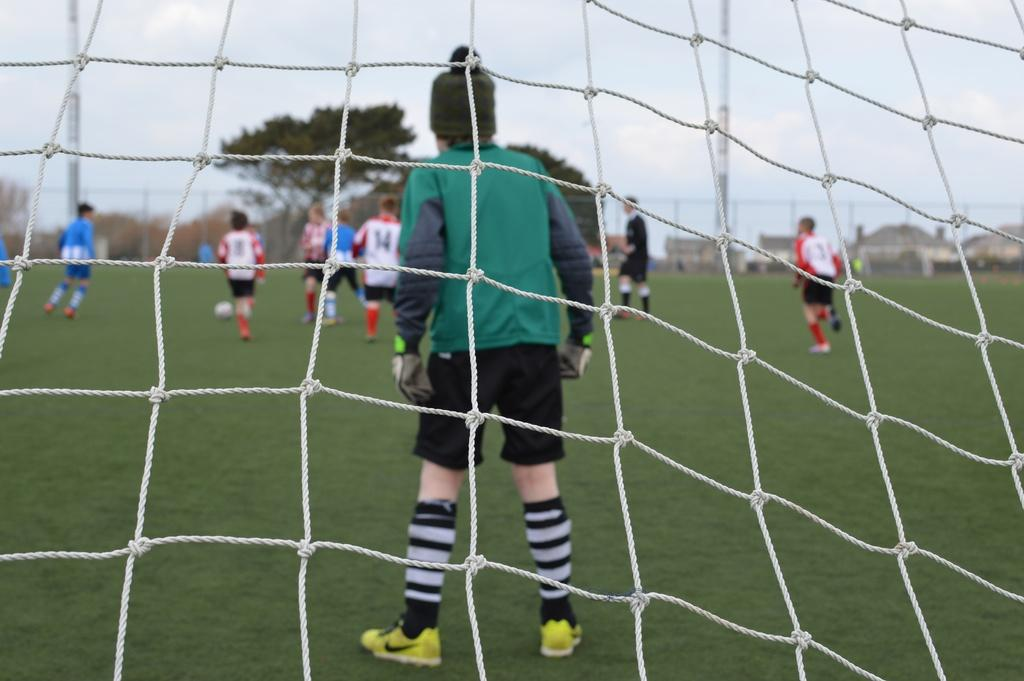Provide a one-sentence caption for the provided image. A view of a goalie in soccer from behind the net with many numbered players such as 14 and 8 in the background. 